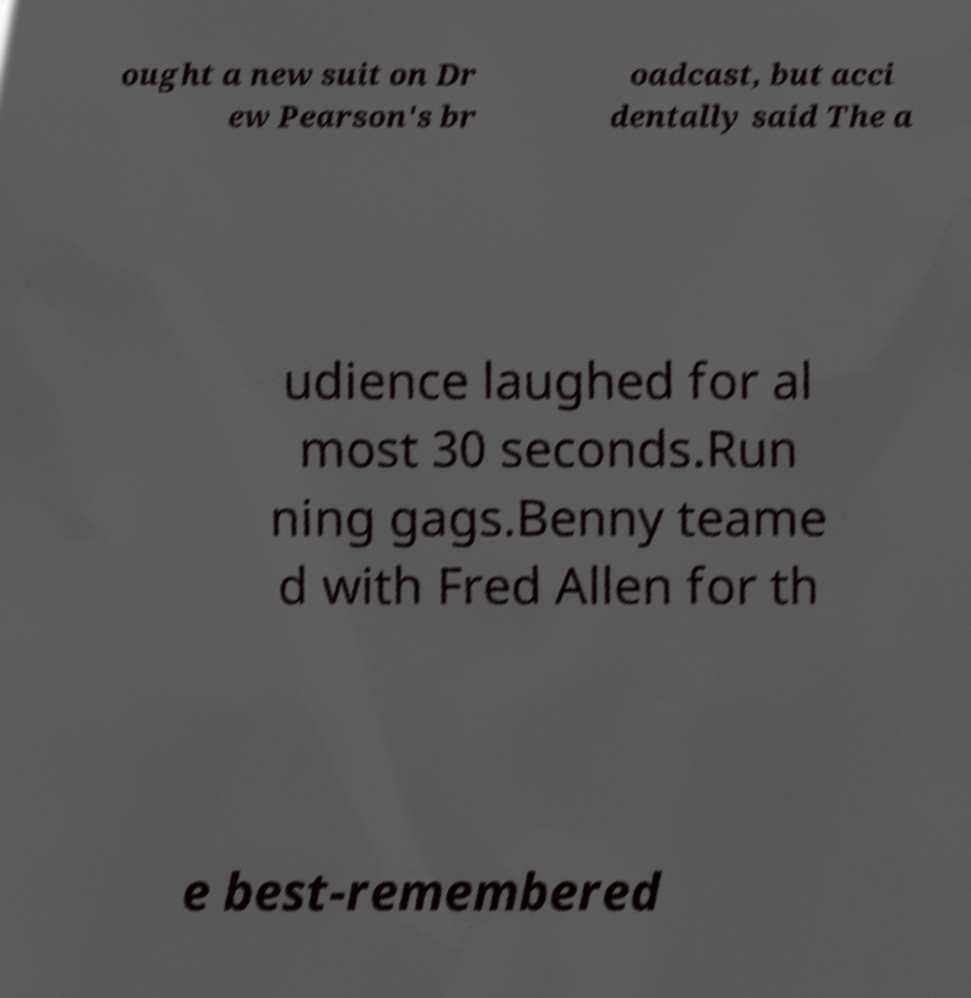Could you extract and type out the text from this image? ought a new suit on Dr ew Pearson's br oadcast, but acci dentally said The a udience laughed for al most 30 seconds.Run ning gags.Benny teame d with Fred Allen for th e best-remembered 